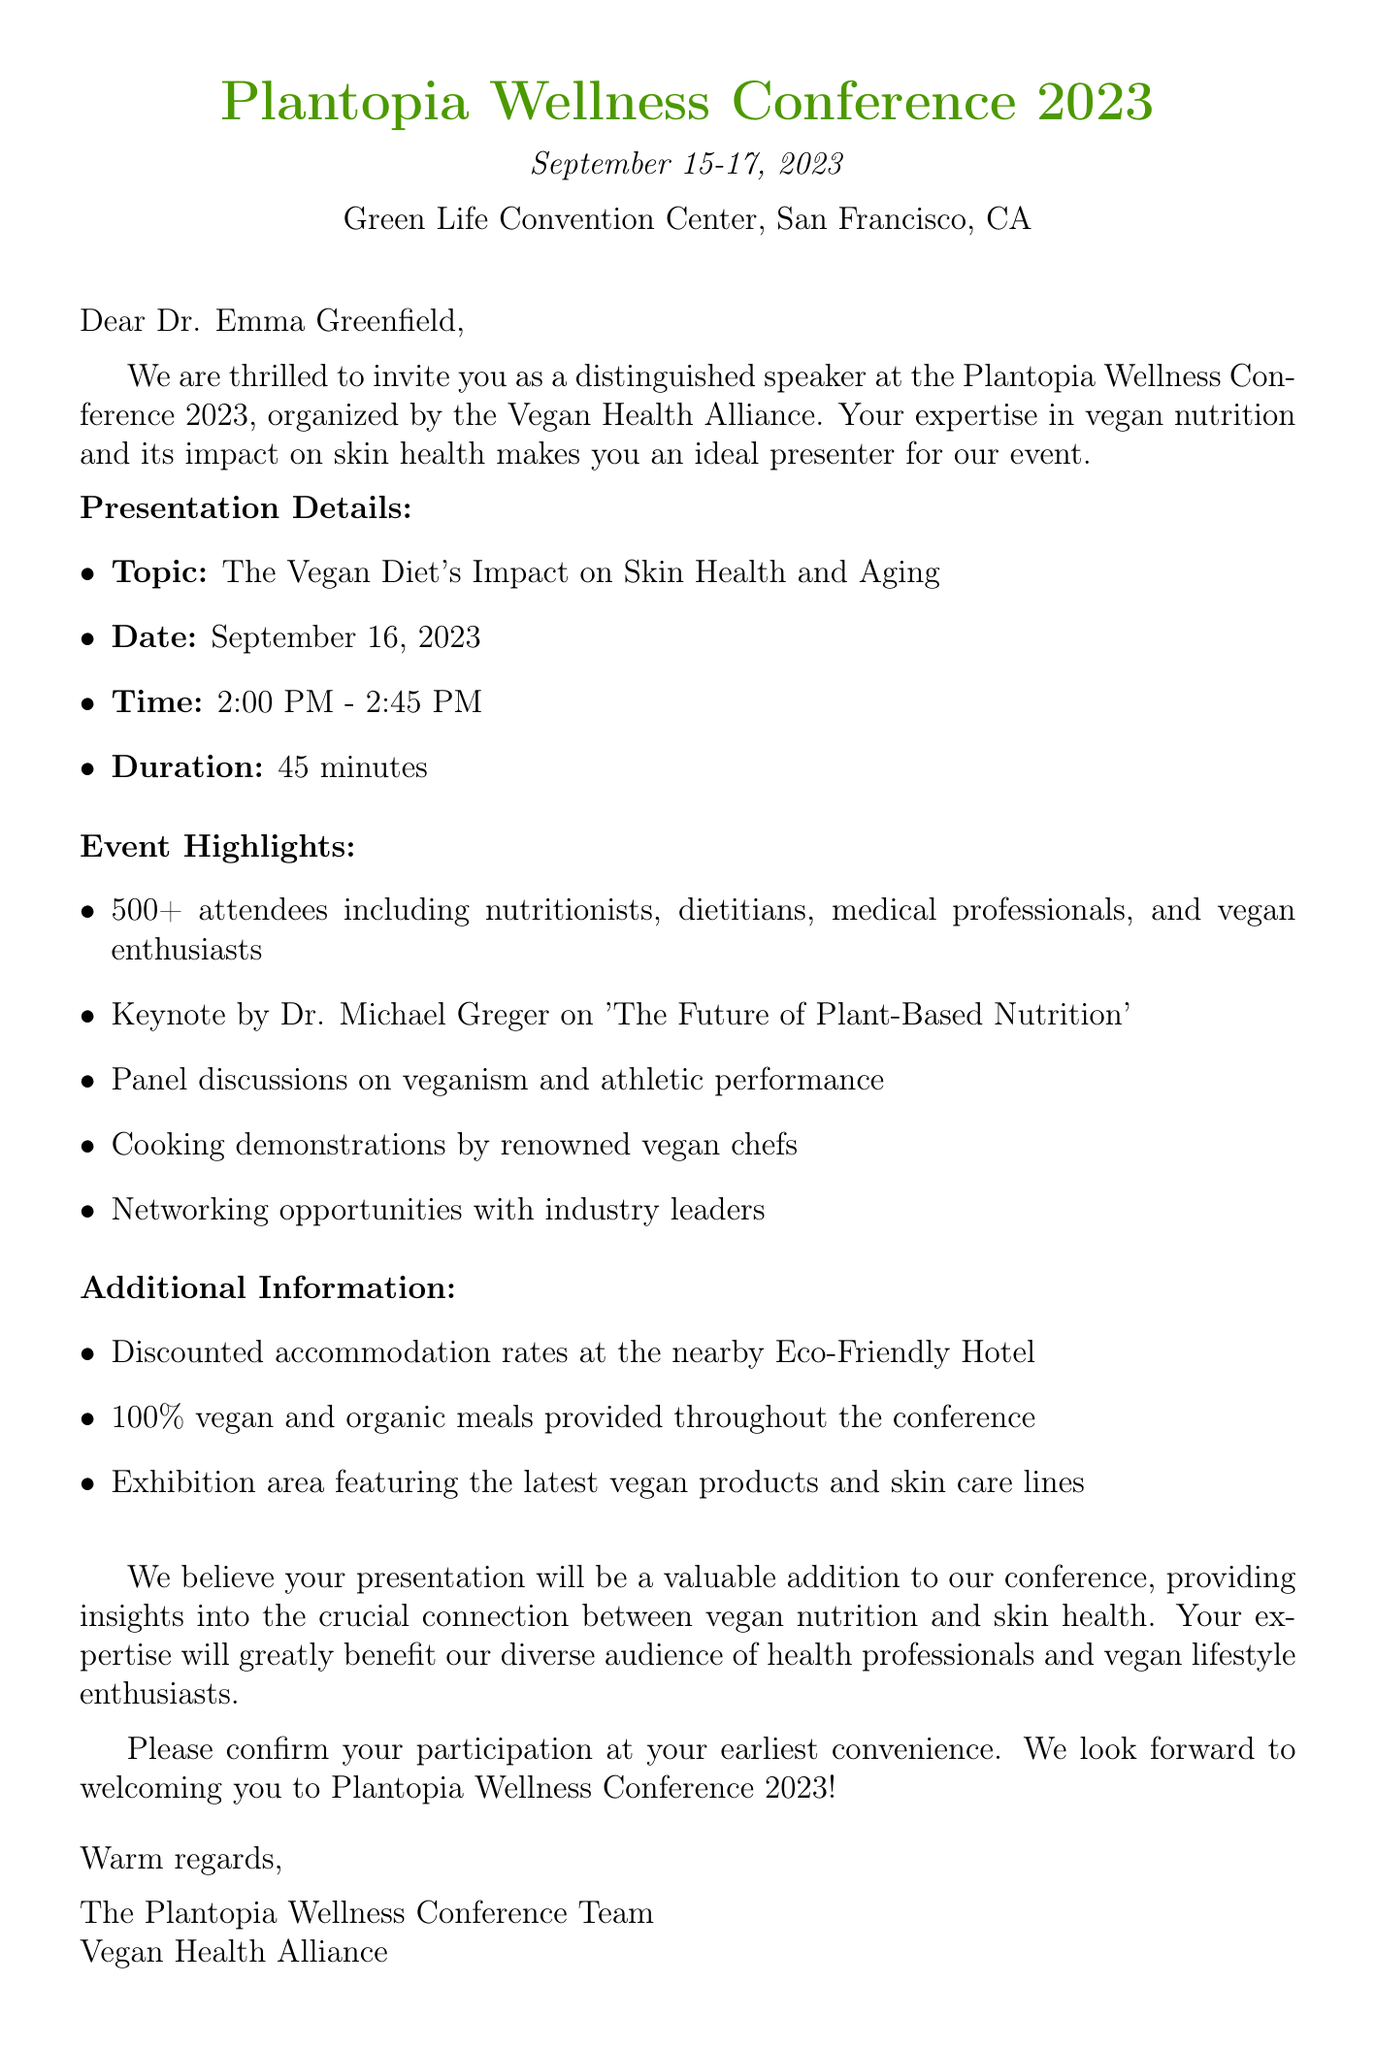What is the event name? The event name is explicitly stated at the beginning of the document.
Answer: Plantopia Wellness Conference 2023 What are the presentation details? The presentation details are listed under the headers of the letter, specifying the topic, date, time, and duration.
Answer: The Vegan Diet's Impact on Skin Health and Aging; September 16, 2023; 2:00 PM - 2:45 PM; 45 minutes How many attendees are expected? The number of expected attendees is directly provided in the expected audience section of the document.
Answer: 500 Who is the keynote speaker? The keynote speaker is mentioned clearly in the event highlights section with their name and topic.
Answer: Dr. Michael Greger What is the format of meals during the conference? The type of meals provided is described in the additional information, detailing the food offerings during the event.
Answer: 100% vegan and organic meals What can the audience expect from the event? The expected benefits and features of the event for the audience are outlined in the event highlights and additional information sections.
Answer: Networking opportunities with industry leaders, cooking demonstrations by renowned vegan chefs What kind of accommodation is available? Accommodation options are detailed in the additional information section of the document.
Answer: Discounted rates available at the nearby Eco-Friendly Hotel When is Dr. Emma Greenfield's presentation scheduled? The specific timing of Dr. Emma Greenfield's presentation is provided in the presentation details section.
Answer: September 16, 2023, 2:00 PM - 2:45 PM What organization is hosting the event? The organization responsible for organizing the event is mentioned in the document.
Answer: Vegan Health Alliance 